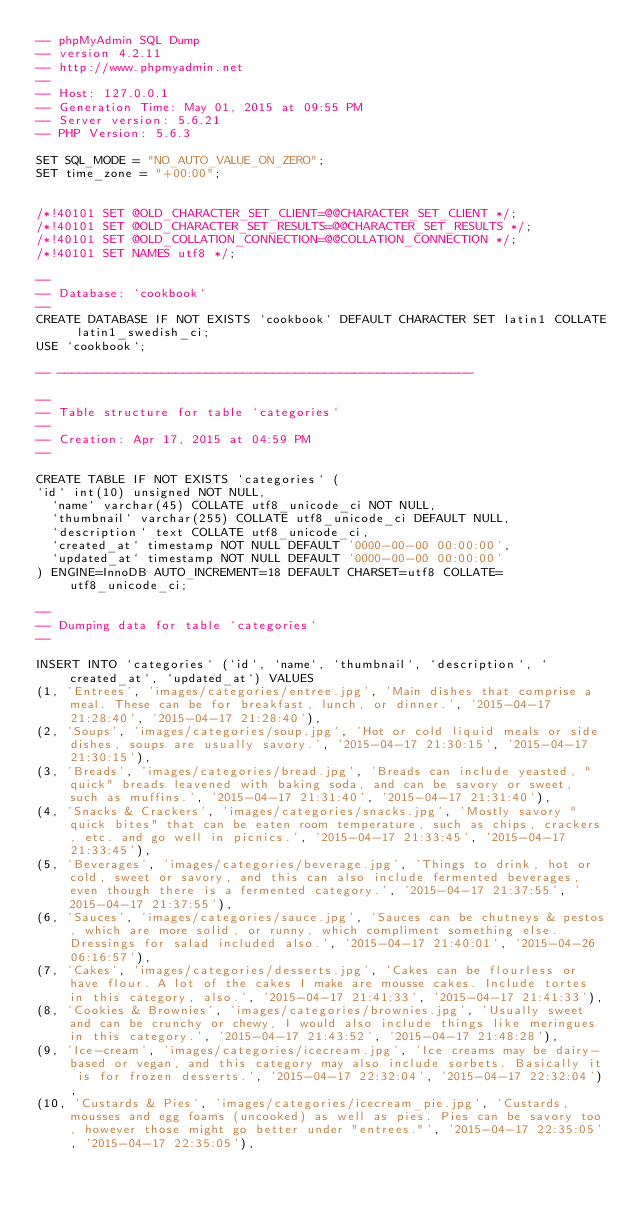Convert code to text. <code><loc_0><loc_0><loc_500><loc_500><_SQL_>-- phpMyAdmin SQL Dump
-- version 4.2.11
-- http://www.phpmyadmin.net
--
-- Host: 127.0.0.1
-- Generation Time: May 01, 2015 at 09:55 PM
-- Server version: 5.6.21
-- PHP Version: 5.6.3

SET SQL_MODE = "NO_AUTO_VALUE_ON_ZERO";
SET time_zone = "+00:00";


/*!40101 SET @OLD_CHARACTER_SET_CLIENT=@@CHARACTER_SET_CLIENT */;
/*!40101 SET @OLD_CHARACTER_SET_RESULTS=@@CHARACTER_SET_RESULTS */;
/*!40101 SET @OLD_COLLATION_CONNECTION=@@COLLATION_CONNECTION */;
/*!40101 SET NAMES utf8 */;

--
-- Database: `cookbook`
--
CREATE DATABASE IF NOT EXISTS `cookbook` DEFAULT CHARACTER SET latin1 COLLATE latin1_swedish_ci;
USE `cookbook`;

-- --------------------------------------------------------

--
-- Table structure for table `categories`
--
-- Creation: Apr 17, 2015 at 04:59 PM
--

CREATE TABLE IF NOT EXISTS `categories` (
`id` int(10) unsigned NOT NULL,
  `name` varchar(45) COLLATE utf8_unicode_ci NOT NULL,
  `thumbnail` varchar(255) COLLATE utf8_unicode_ci DEFAULT NULL,
  `description` text COLLATE utf8_unicode_ci,
  `created_at` timestamp NOT NULL DEFAULT '0000-00-00 00:00:00',
  `updated_at` timestamp NOT NULL DEFAULT '0000-00-00 00:00:00'
) ENGINE=InnoDB AUTO_INCREMENT=18 DEFAULT CHARSET=utf8 COLLATE=utf8_unicode_ci;

--
-- Dumping data for table `categories`
--

INSERT INTO `categories` (`id`, `name`, `thumbnail`, `description`, `created_at`, `updated_at`) VALUES
(1, 'Entrees', 'images/categories/entree.jpg', 'Main dishes that comprise a meal. These can be for breakfast, lunch, or dinner.', '2015-04-17 21:28:40', '2015-04-17 21:28:40'),
(2, 'Soups', 'images/categories/soup.jpg', 'Hot or cold liquid meals or side dishes, soups are usually savory.', '2015-04-17 21:30:15', '2015-04-17 21:30:15'),
(3, 'Breads', 'images/categories/bread.jpg', 'Breads can include yeasted, "quick" breads leavened with baking soda, and can be savory or sweet, such as muffins.', '2015-04-17 21:31:40', '2015-04-17 21:31:40'),
(4, 'Snacks & Crackers', 'images/categories/snacks.jpg', 'Mostly savory "quick bites" that can be eaten room temperature, such as chips, crackers, etc. and go well in picnics.', '2015-04-17 21:33:45', '2015-04-17 21:33:45'),
(5, 'Beverages', 'images/categories/beverage.jpg', 'Things to drink, hot or cold, sweet or savory, and this can also include fermented beverages, even though there is a fermented category.', '2015-04-17 21:37:55', '2015-04-17 21:37:55'),
(6, 'Sauces', 'images/categories/sauce.jpg', 'Sauces can be chutneys & pestos, which are more solid, or runny, which compliment something else. Dressings for salad included also.', '2015-04-17 21:40:01', '2015-04-26 06:16:57'),
(7, 'Cakes', 'images/categories/desserts.jpg', 'Cakes can be flourless or have flour. A lot of the cakes I make are mousse cakes. Include tortes in this category, also.', '2015-04-17 21:41:33', '2015-04-17 21:41:33'),
(8, 'Cookies & Brownies', 'images/categories/brownies.jpg', 'Usually sweet and can be crunchy or chewy, I would also include things like meringues in this category.', '2015-04-17 21:43:52', '2015-04-17 21:48:28'),
(9, 'Ice-cream', 'images/categories/icecream.jpg', 'Ice creams may be dairy-based or vegan, and this category may also include sorbets. Basically it is for frozen desserts.', '2015-04-17 22:32:04', '2015-04-17 22:32:04'),
(10, 'Custards & Pies', 'images/categories/icecream_pie.jpg', 'Custards, mousses and egg foams (uncooked) as well as pies. Pies can be savory too, however those might go better under "entrees."', '2015-04-17 22:35:05', '2015-04-17 22:35:05'),</code> 